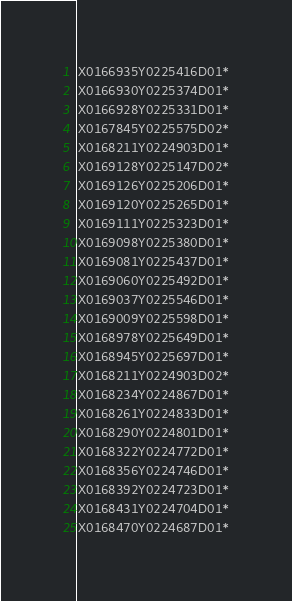<code> <loc_0><loc_0><loc_500><loc_500><_SQL_>X0166935Y0225416D01*
X0166930Y0225374D01*
X0166928Y0225331D01*
X0167845Y0225575D02*
X0168211Y0224903D01*
X0169128Y0225147D02*
X0169126Y0225206D01*
X0169120Y0225265D01*
X0169111Y0225323D01*
X0169098Y0225380D01*
X0169081Y0225437D01*
X0169060Y0225492D01*
X0169037Y0225546D01*
X0169009Y0225598D01*
X0168978Y0225649D01*
X0168945Y0225697D01*
X0168211Y0224903D02*
X0168234Y0224867D01*
X0168261Y0224833D01*
X0168290Y0224801D01*
X0168322Y0224772D01*
X0168356Y0224746D01*
X0168392Y0224723D01*
X0168431Y0224704D01*
X0168470Y0224687D01*</code> 